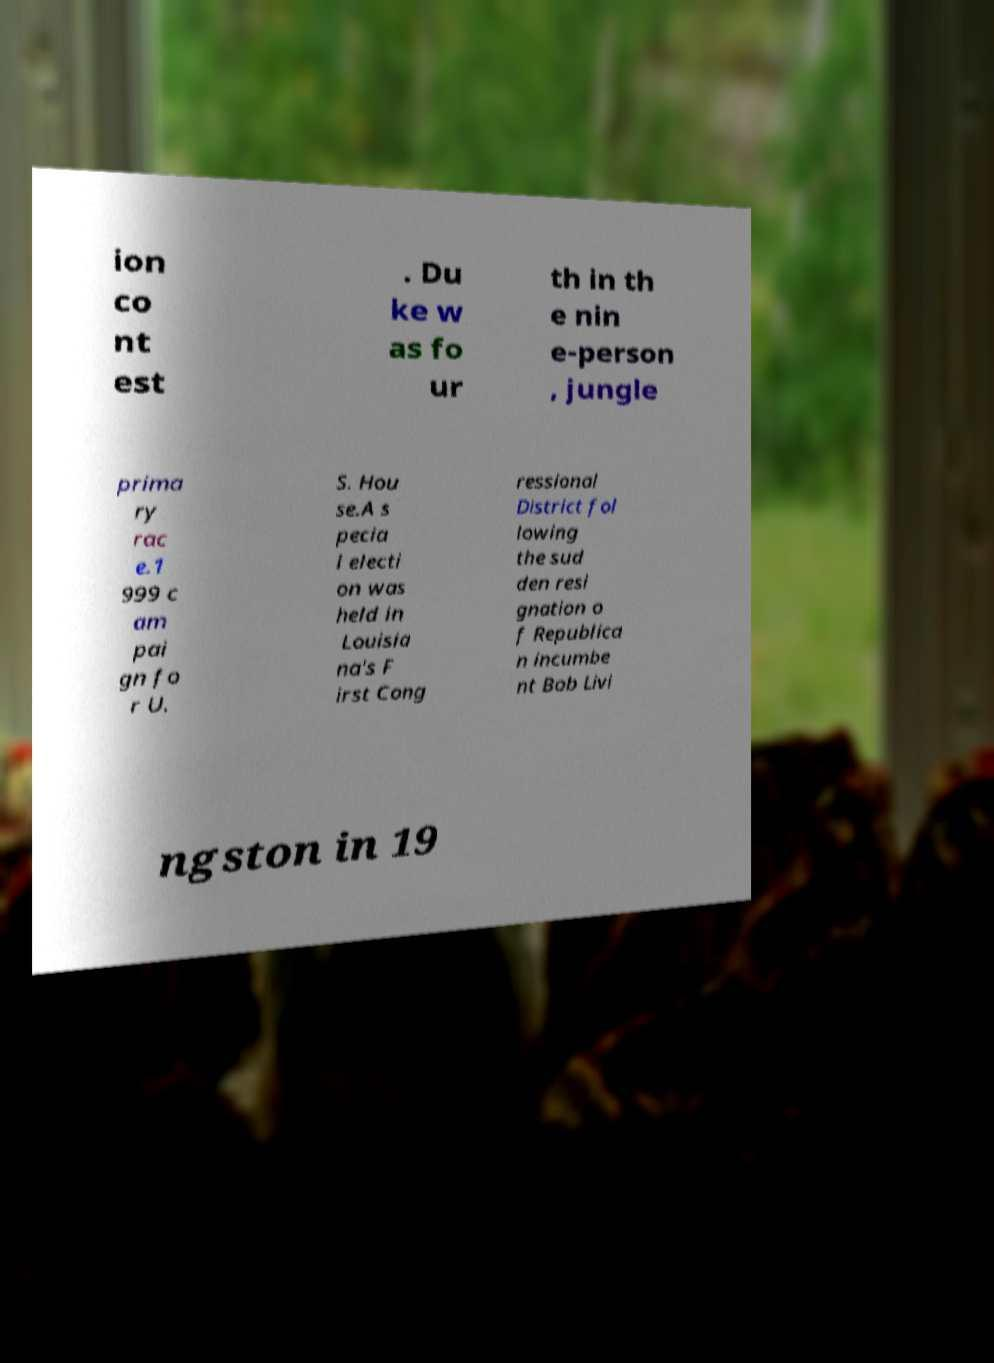Could you extract and type out the text from this image? ion co nt est . Du ke w as fo ur th in th e nin e-person , jungle prima ry rac e.1 999 c am pai gn fo r U. S. Hou se.A s pecia l electi on was held in Louisia na's F irst Cong ressional District fol lowing the sud den resi gnation o f Republica n incumbe nt Bob Livi ngston in 19 